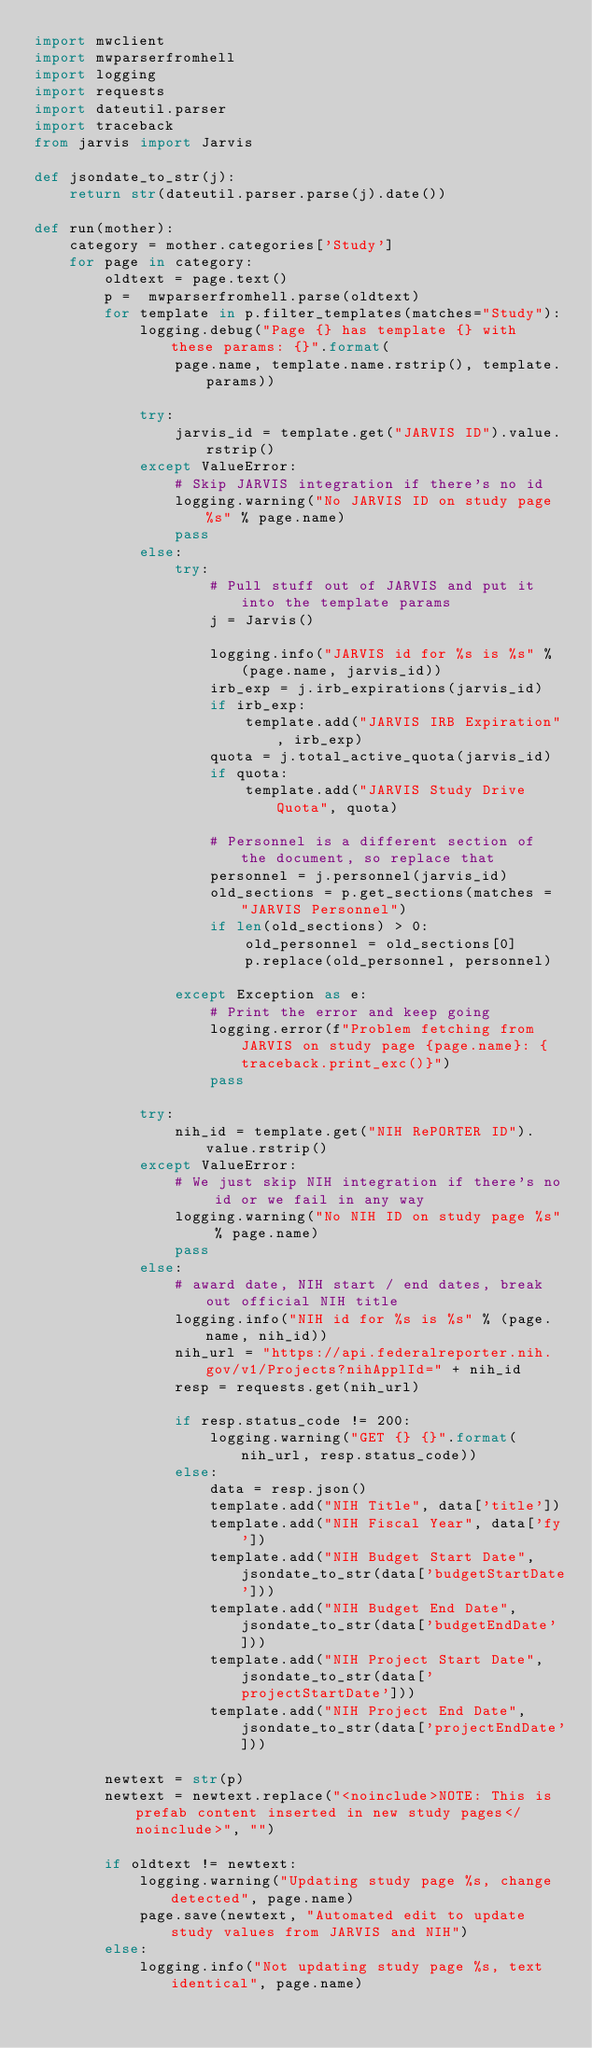Convert code to text. <code><loc_0><loc_0><loc_500><loc_500><_Python_>import mwclient
import mwparserfromhell
import logging
import requests
import dateutil.parser
import traceback
from jarvis import Jarvis

def jsondate_to_str(j):
    return str(dateutil.parser.parse(j).date())

def run(mother):
    category = mother.categories['Study']
    for page in category:
        oldtext = page.text()
        p =  mwparserfromhell.parse(oldtext)
        for template in p.filter_templates(matches="Study"):
            logging.debug("Page {} has template {} with these params: {}".format(
                page.name, template.name.rstrip(), template.params))

            try:
                jarvis_id = template.get("JARVIS ID").value.rstrip()
            except ValueError:
                # Skip JARVIS integration if there's no id
                logging.warning("No JARVIS ID on study page %s" % page.name)
                pass
            else:
                try:
                    # Pull stuff out of JARVIS and put it into the template params
                    j = Jarvis()

                    logging.info("JARVIS id for %s is %s" % (page.name, jarvis_id))
                    irb_exp = j.irb_expirations(jarvis_id)
                    if irb_exp:
                        template.add("JARVIS IRB Expiration", irb_exp)
                    quota = j.total_active_quota(jarvis_id)
                    if quota:
                        template.add("JARVIS Study Drive Quota", quota)
                    
                    # Personnel is a different section of the document, so replace that
                    personnel = j.personnel(jarvis_id)
                    old_sections = p.get_sections(matches = "JARVIS Personnel")
                    if len(old_sections) > 0:
                        old_personnel = old_sections[0]
                        p.replace(old_personnel, personnel)

                except Exception as e:
                    # Print the error and keep going
                    logging.error(f"Problem fetching from JARVIS on study page {page.name}: {traceback.print_exc()}")
                    pass

            try:
                nih_id = template.get("NIH RePORTER ID").value.rstrip()
            except ValueError:
                # We just skip NIH integration if there's no id or we fail in any way
                logging.warning("No NIH ID on study page %s" % page.name)
                pass
            else:
                # award date, NIH start / end dates, break out official NIH title
                logging.info("NIH id for %s is %s" % (page.name, nih_id))
                nih_url = "https://api.federalreporter.nih.gov/v1/Projects?nihApplId=" + nih_id
                resp = requests.get(nih_url)

                if resp.status_code != 200:
                    logging.warning("GET {} {}".format(nih_url, resp.status_code))
                else:
                    data = resp.json()
                    template.add("NIH Title", data['title'])
                    template.add("NIH Fiscal Year", data['fy'])
                    template.add("NIH Budget Start Date", jsondate_to_str(data['budgetStartDate']))
                    template.add("NIH Budget End Date", jsondate_to_str(data['budgetEndDate']))
                    template.add("NIH Project Start Date", jsondate_to_str(data['projectStartDate']))
                    template.add("NIH Project End Date", jsondate_to_str(data['projectEndDate']))

        newtext = str(p)
        newtext = newtext.replace("<noinclude>NOTE: This is prefab content inserted in new study pages</noinclude>", "")

        if oldtext != newtext:
            logging.warning("Updating study page %s, change detected", page.name)
            page.save(newtext, "Automated edit to update study values from JARVIS and NIH")
        else:
            logging.info("Not updating study page %s, text identical", page.name)
</code> 